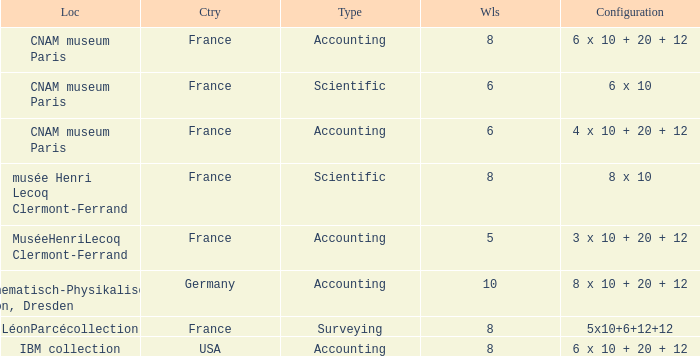What location has surveying as the type? LéonParcécollection. 